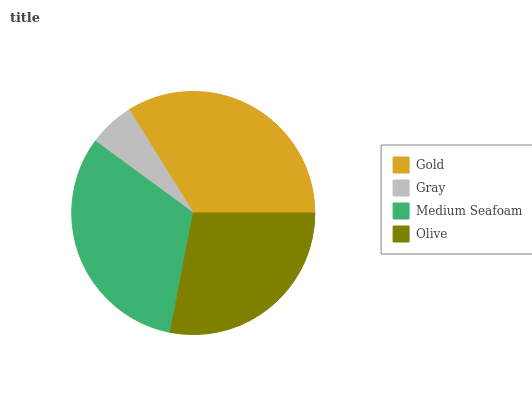Is Gray the minimum?
Answer yes or no. Yes. Is Gold the maximum?
Answer yes or no. Yes. Is Medium Seafoam the minimum?
Answer yes or no. No. Is Medium Seafoam the maximum?
Answer yes or no. No. Is Medium Seafoam greater than Gray?
Answer yes or no. Yes. Is Gray less than Medium Seafoam?
Answer yes or no. Yes. Is Gray greater than Medium Seafoam?
Answer yes or no. No. Is Medium Seafoam less than Gray?
Answer yes or no. No. Is Medium Seafoam the high median?
Answer yes or no. Yes. Is Olive the low median?
Answer yes or no. Yes. Is Gray the high median?
Answer yes or no. No. Is Medium Seafoam the low median?
Answer yes or no. No. 